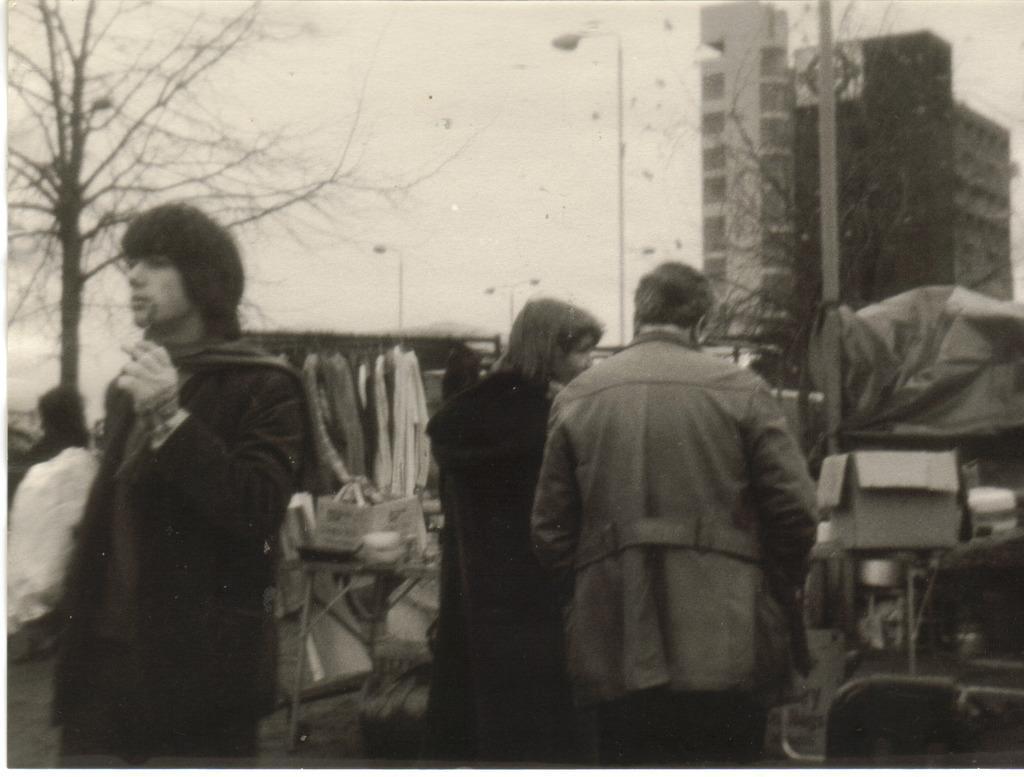Can you describe this image briefly? It is a black and white image. In the image there are few people standing. In front of them there are cardboard boxes, tables and few other items. In the background there are trees, poles with street lights and buildings. Also in the background there is a sky. 